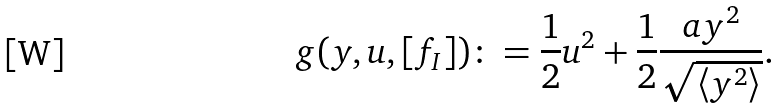Convert formula to latex. <formula><loc_0><loc_0><loc_500><loc_500>g ( y , u , [ f _ { I } ] ) \colon = \frac { 1 } { 2 } u ^ { 2 } + \frac { 1 } { 2 } \frac { a y ^ { 2 } } { \sqrt { \left \langle y ^ { 2 } \right \rangle } } .</formula> 